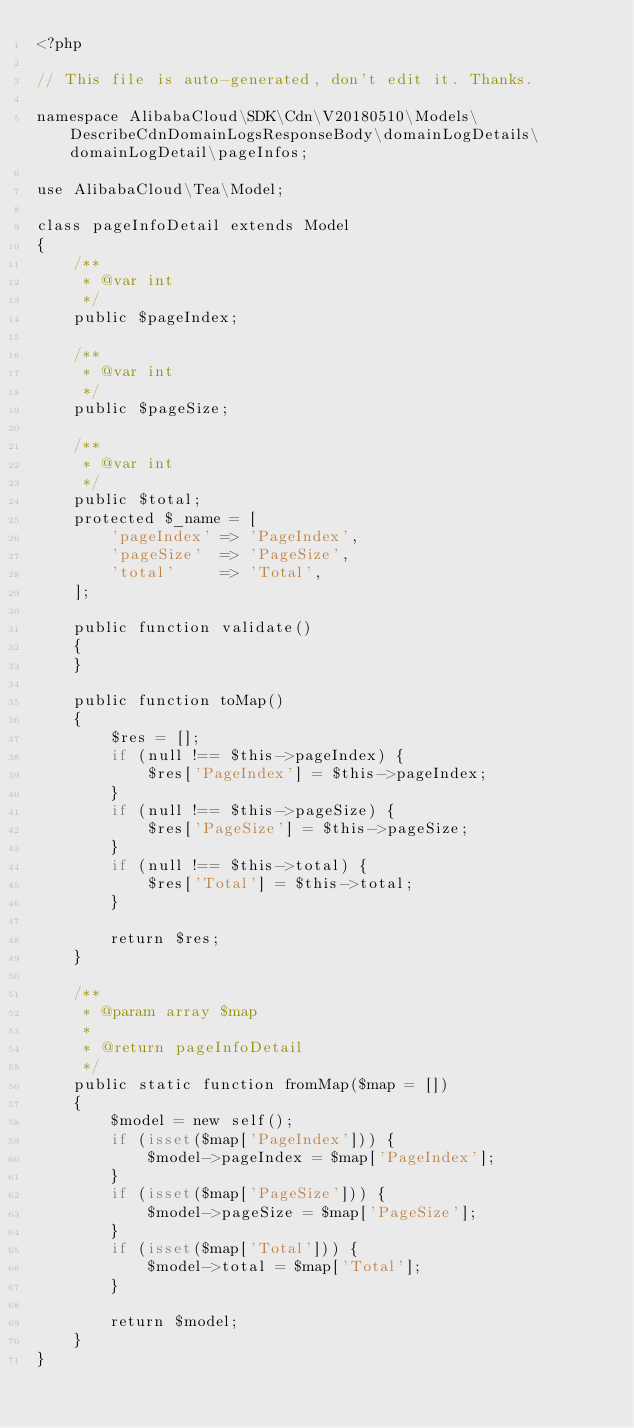<code> <loc_0><loc_0><loc_500><loc_500><_PHP_><?php

// This file is auto-generated, don't edit it. Thanks.

namespace AlibabaCloud\SDK\Cdn\V20180510\Models\DescribeCdnDomainLogsResponseBody\domainLogDetails\domainLogDetail\pageInfos;

use AlibabaCloud\Tea\Model;

class pageInfoDetail extends Model
{
    /**
     * @var int
     */
    public $pageIndex;

    /**
     * @var int
     */
    public $pageSize;

    /**
     * @var int
     */
    public $total;
    protected $_name = [
        'pageIndex' => 'PageIndex',
        'pageSize'  => 'PageSize',
        'total'     => 'Total',
    ];

    public function validate()
    {
    }

    public function toMap()
    {
        $res = [];
        if (null !== $this->pageIndex) {
            $res['PageIndex'] = $this->pageIndex;
        }
        if (null !== $this->pageSize) {
            $res['PageSize'] = $this->pageSize;
        }
        if (null !== $this->total) {
            $res['Total'] = $this->total;
        }

        return $res;
    }

    /**
     * @param array $map
     *
     * @return pageInfoDetail
     */
    public static function fromMap($map = [])
    {
        $model = new self();
        if (isset($map['PageIndex'])) {
            $model->pageIndex = $map['PageIndex'];
        }
        if (isset($map['PageSize'])) {
            $model->pageSize = $map['PageSize'];
        }
        if (isset($map['Total'])) {
            $model->total = $map['Total'];
        }

        return $model;
    }
}
</code> 